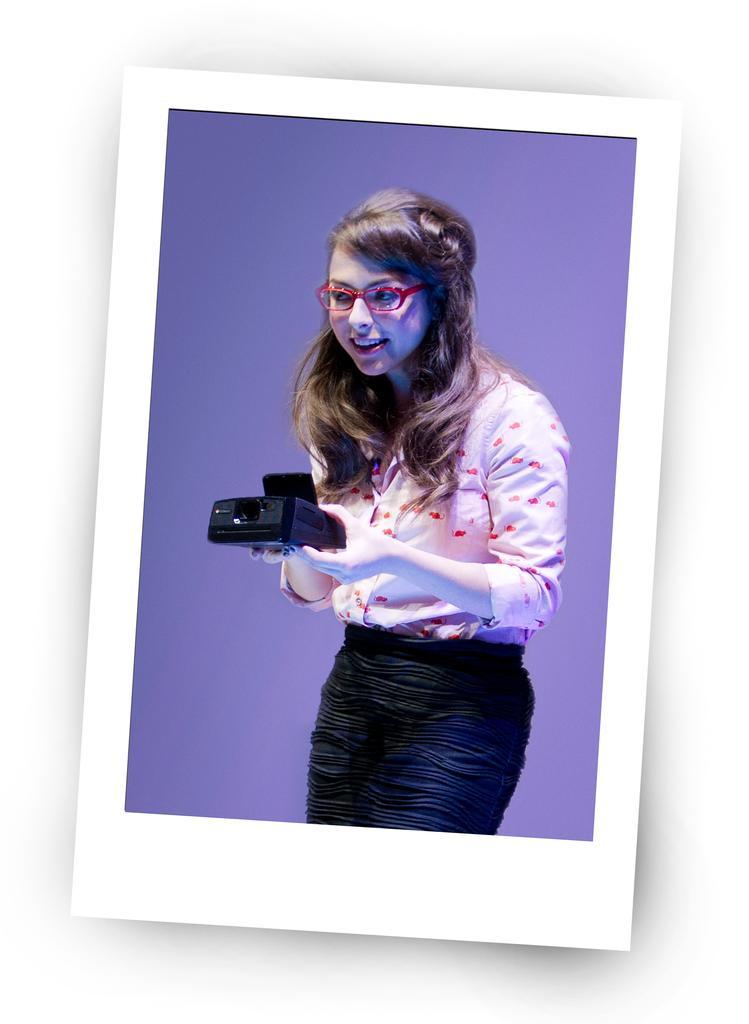Please provide a concise description of this image. In this image we can see a photograph of a lady. She is holding an object. 